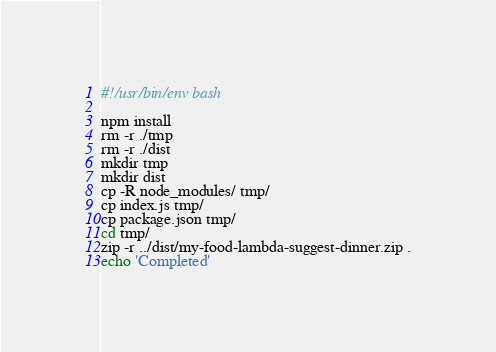<code> <loc_0><loc_0><loc_500><loc_500><_Bash_>#!/usr/bin/env bash

npm install
rm -r ./tmp
rm -r ./dist
mkdir tmp
mkdir dist
cp -R node_modules/ tmp/
cp index.js tmp/
cp package.json tmp/
cd tmp/
zip -r ../dist/my-food-lambda-suggest-dinner.zip .
echo 'Completed'</code> 